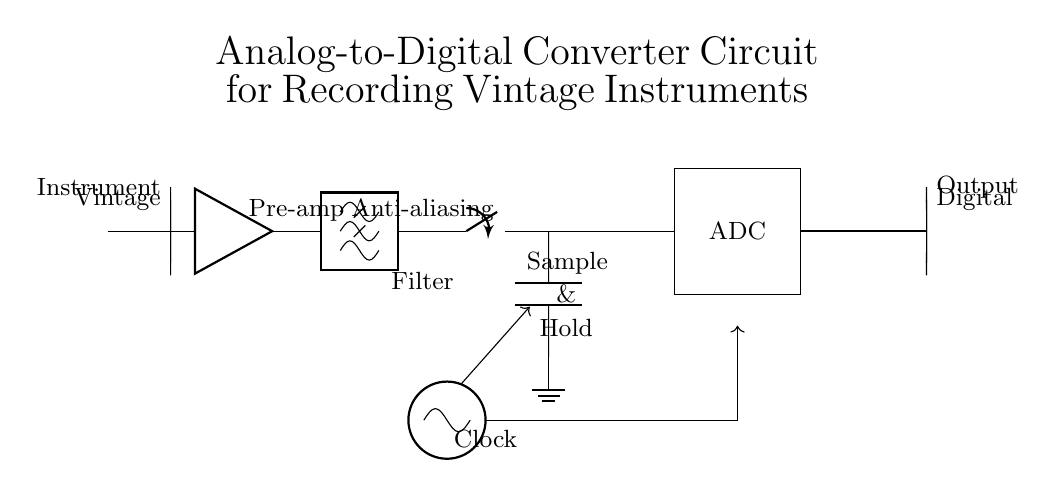What is the main purpose of this circuit? The main purpose of the circuit is to convert analog signals from vintage instruments into digital signals for recording. This is seen through the sequence of components starting from the vintage instrument leading to the ADC.
Answer: Analog-to-Digital Conversion What component comes after the pre-amplifier? The component that comes after the pre-amplifier is the lowpass filter, specifically the anti-aliasing filter which ensures that frequency components above a certain threshold are filtered out. This helps prevent aliasing before sampling.
Answer: Anti-aliasing filter How many main processing steps are shown in this circuit? There are four main processing steps: the vintage instrument input, pre-amplification, filtering, and finally analog-to-digital conversion, which illustrates the route an analog signal takes to become digital.
Answer: Four What is the function of the sample and hold circuit? The sample and hold circuit captures the analog signal at a specific moment in time and holds that value until it can be processed by the ADC, ensuring an accurate reading of the voltage level during conversion.
Answer: Captures and holds the voltage What does the clock symbol represent in this circuit? The clock symbol represents the timing mechanism that governs when the ADC takes samples of the incoming analog signal, ensuring that the conversion occurs at precise intervals.
Answer: Timing mechanism Which component directly provides the digital output in the circuit? The directly providing component for the digital output in the circuit is the ADC (Analog-to-Digital Converter), which performs the conversion from analog voltage levels to digital values.
Answer: ADC What kind of filter is used in this circuit? The type of filter used in this circuit is a lowpass filter, which is designed to allow signals below a certain cutoff frequency to pass and attenuate signals above this frequency.
Answer: Lowpass filter 